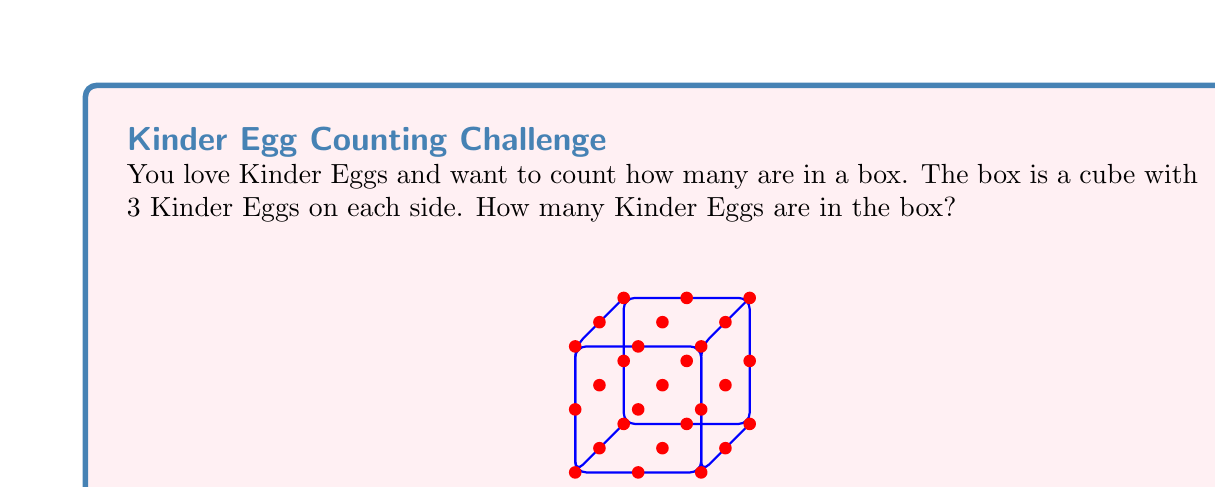Show me your answer to this math problem. Let's approach this step-by-step:

1) First, we need to understand what the question is asking. We have a cube-shaped box, and there are 3 Kinder Eggs along each edge of the cube.

2) In ring theory, we can think of this as a 3-dimensional array or a 3x3x3 matrix.

3) To find the total number of Kinder Eggs, we need to calculate the volume of this cube in terms of Kinder Eggs.

4) The formula for the volume of a cube is:

   $$V = s^3$$

   where $s$ is the length of one side.

5) In this case, $s = 3$ (3 Kinder Eggs on each side).

6) So, we can calculate:

   $$V = 3^3 = 3 \times 3 \times 3 = 27$$

7) Therefore, there are 27 Kinder Eggs in the box.

This problem introduces the concept of cubic numbers, which are important in ring theory and many other areas of mathematics.
Answer: 27 Kinder Eggs 